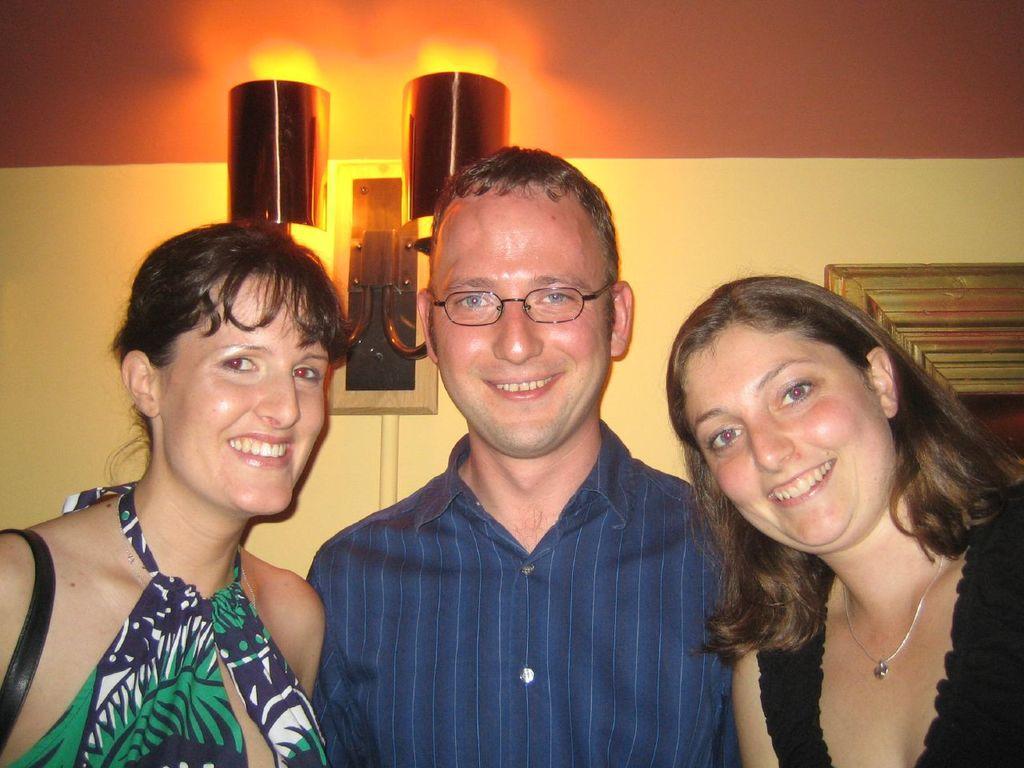Describe this image in one or two sentences. This picture consists of three persons they are smiling, in the background I can see the wall , on the wall I can see a lamp attached to it , through lamp I can see a light and a photo frame attached to the wall on the right side. 